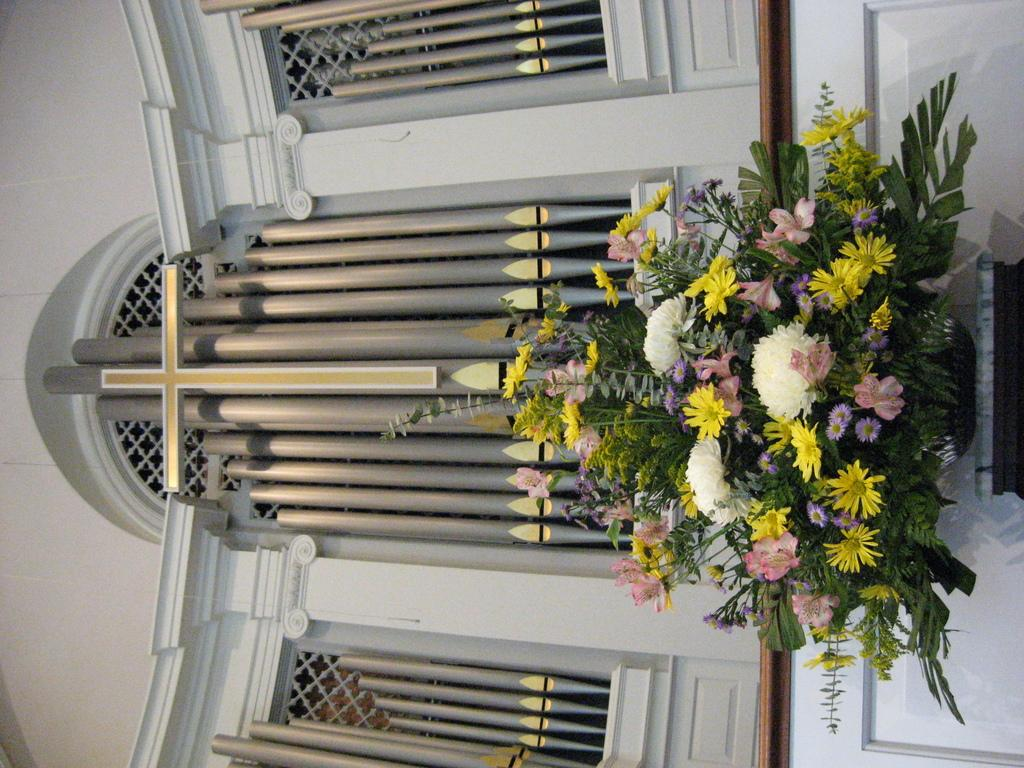What type of location is depicted in the image? The image shows an inner view of a building. What religious symbol can be seen in the image? There is a cross in the image. What type of decoration is present in the image? There is a flower bouquet in the image. What level of expertise does the queen have in lifting heavy objects in the image? There is no queen or lifting of heavy objects present in the image. 